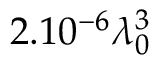<formula> <loc_0><loc_0><loc_500><loc_500>2 . 1 0 ^ { - 6 } \lambda _ { 0 } ^ { 3 }</formula> 